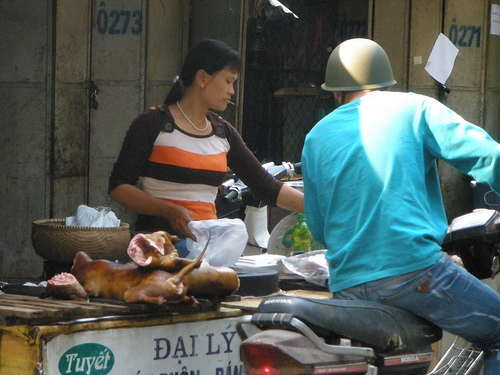<image>
Can you confirm if the helmet is on the head? No. The helmet is not positioned on the head. They may be near each other, but the helmet is not supported by or resting on top of the head. 